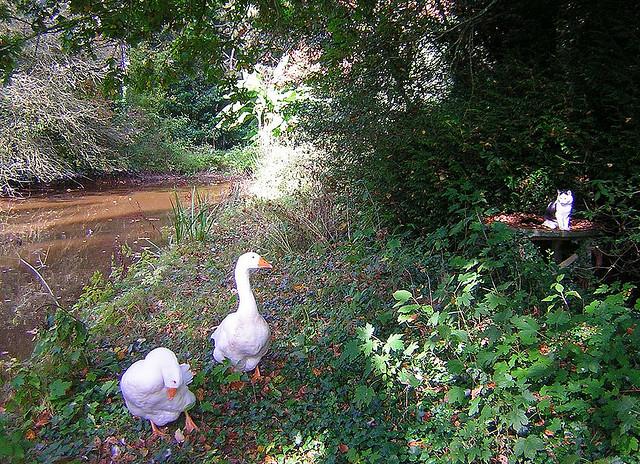What color is the water?
Concise answer only. Brown. How many different species of animals can be seen in this picture?
Answer briefly. 2. What is the back goose doing?
Be succinct. Looking at cat. Are these swallows?
Be succinct. No. 